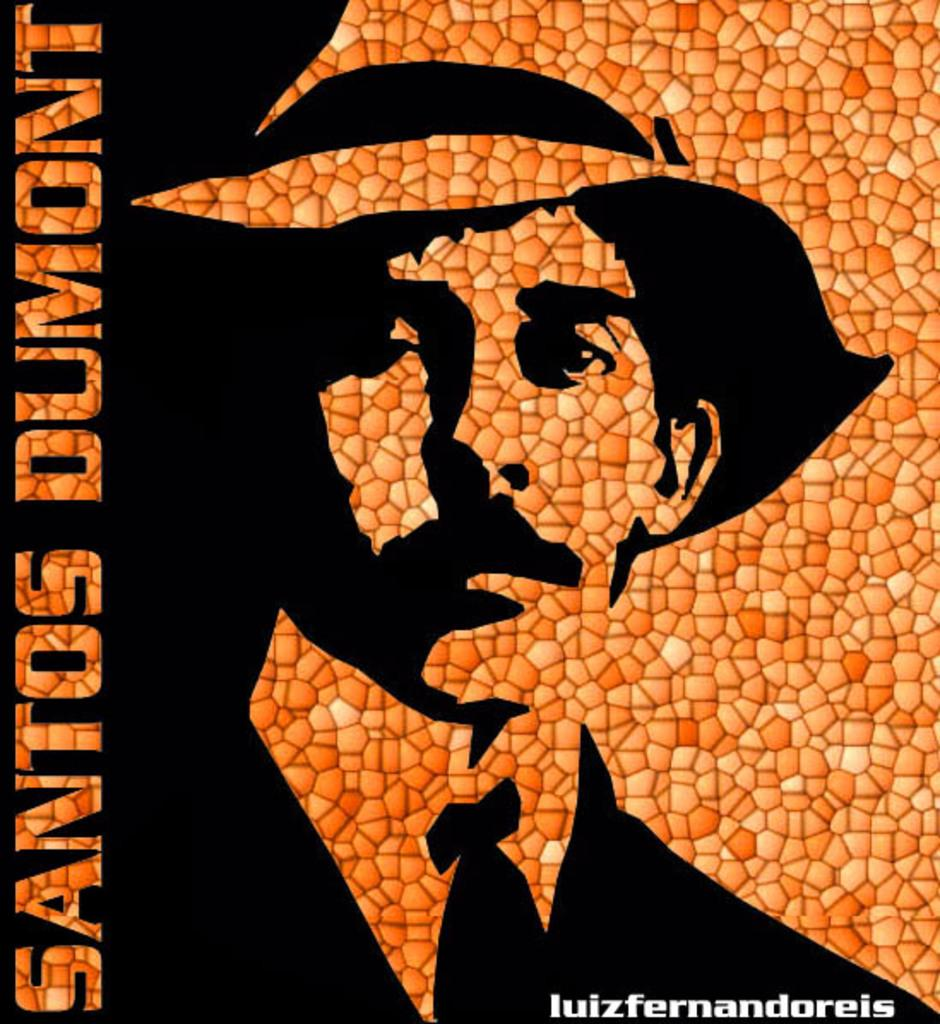<image>
Present a compact description of the photo's key features. Black and orange artwork that has Santos Dumont written on the side. 